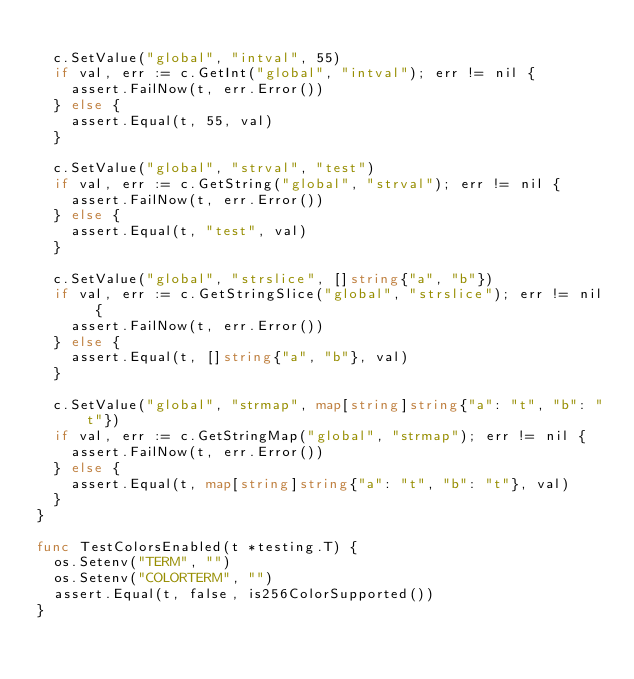Convert code to text. <code><loc_0><loc_0><loc_500><loc_500><_Go_>
	c.SetValue("global", "intval", 55)
	if val, err := c.GetInt("global", "intval"); err != nil {
		assert.FailNow(t, err.Error())
	} else {
		assert.Equal(t, 55, val)
	}

	c.SetValue("global", "strval", "test")
	if val, err := c.GetString("global", "strval"); err != nil {
		assert.FailNow(t, err.Error())
	} else {
		assert.Equal(t, "test", val)
	}

	c.SetValue("global", "strslice", []string{"a", "b"})
	if val, err := c.GetStringSlice("global", "strslice"); err != nil {
		assert.FailNow(t, err.Error())
	} else {
		assert.Equal(t, []string{"a", "b"}, val)
	}

	c.SetValue("global", "strmap", map[string]string{"a": "t", "b": "t"})
	if val, err := c.GetStringMap("global", "strmap"); err != nil {
		assert.FailNow(t, err.Error())
	} else {
		assert.Equal(t, map[string]string{"a": "t", "b": "t"}, val)
	}
}

func TestColorsEnabled(t *testing.T) {
	os.Setenv("TERM", "")
	os.Setenv("COLORTERM", "")
	assert.Equal(t, false, is256ColorSupported())
}
</code> 